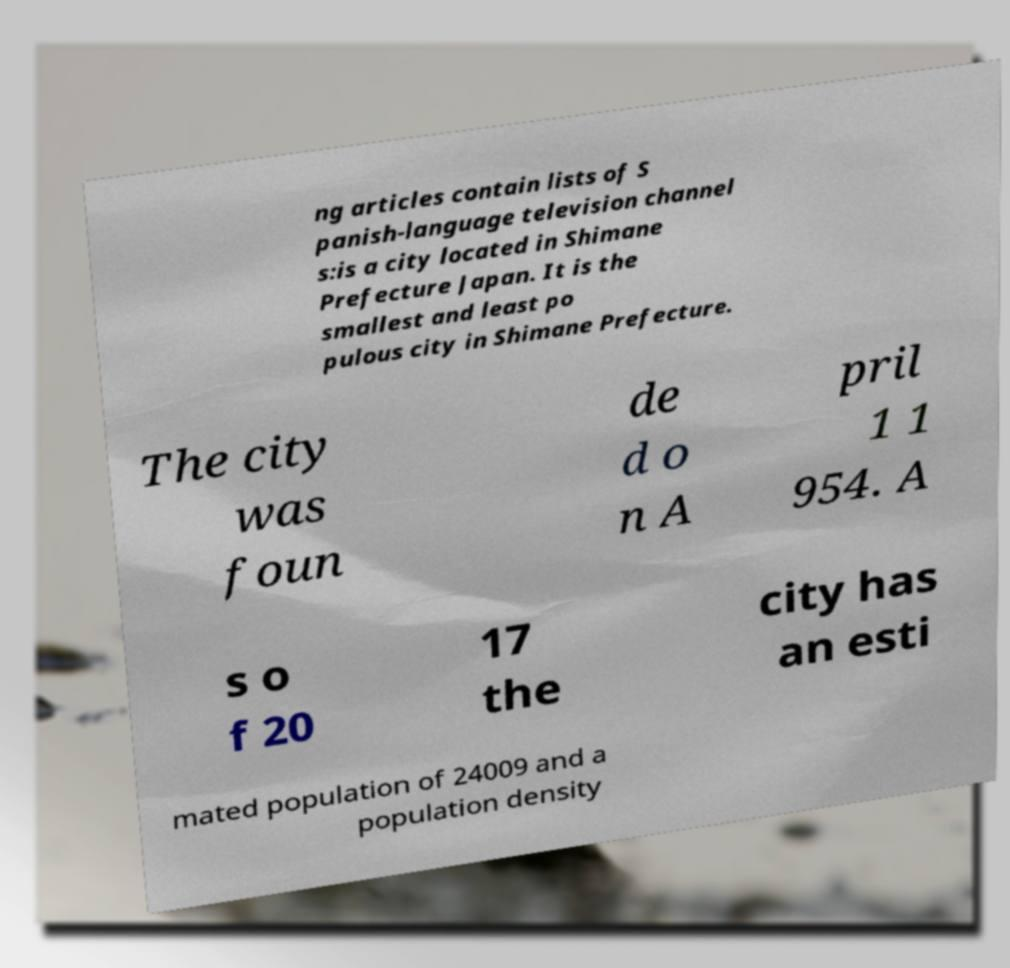There's text embedded in this image that I need extracted. Can you transcribe it verbatim? ng articles contain lists of S panish-language television channel s:is a city located in Shimane Prefecture Japan. It is the smallest and least po pulous city in Shimane Prefecture. The city was foun de d o n A pril 1 1 954. A s o f 20 17 the city has an esti mated population of 24009 and a population density 